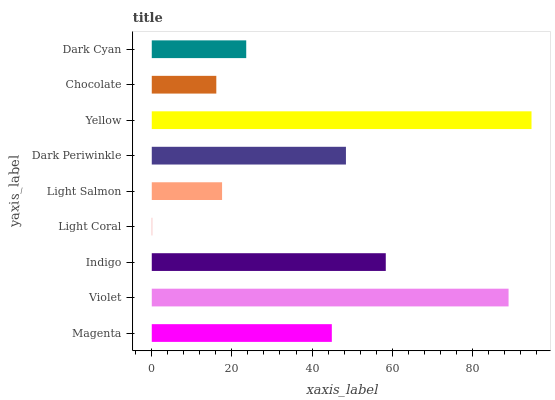Is Light Coral the minimum?
Answer yes or no. Yes. Is Yellow the maximum?
Answer yes or no. Yes. Is Violet the minimum?
Answer yes or no. No. Is Violet the maximum?
Answer yes or no. No. Is Violet greater than Magenta?
Answer yes or no. Yes. Is Magenta less than Violet?
Answer yes or no. Yes. Is Magenta greater than Violet?
Answer yes or no. No. Is Violet less than Magenta?
Answer yes or no. No. Is Magenta the high median?
Answer yes or no. Yes. Is Magenta the low median?
Answer yes or no. Yes. Is Violet the high median?
Answer yes or no. No. Is Light Coral the low median?
Answer yes or no. No. 